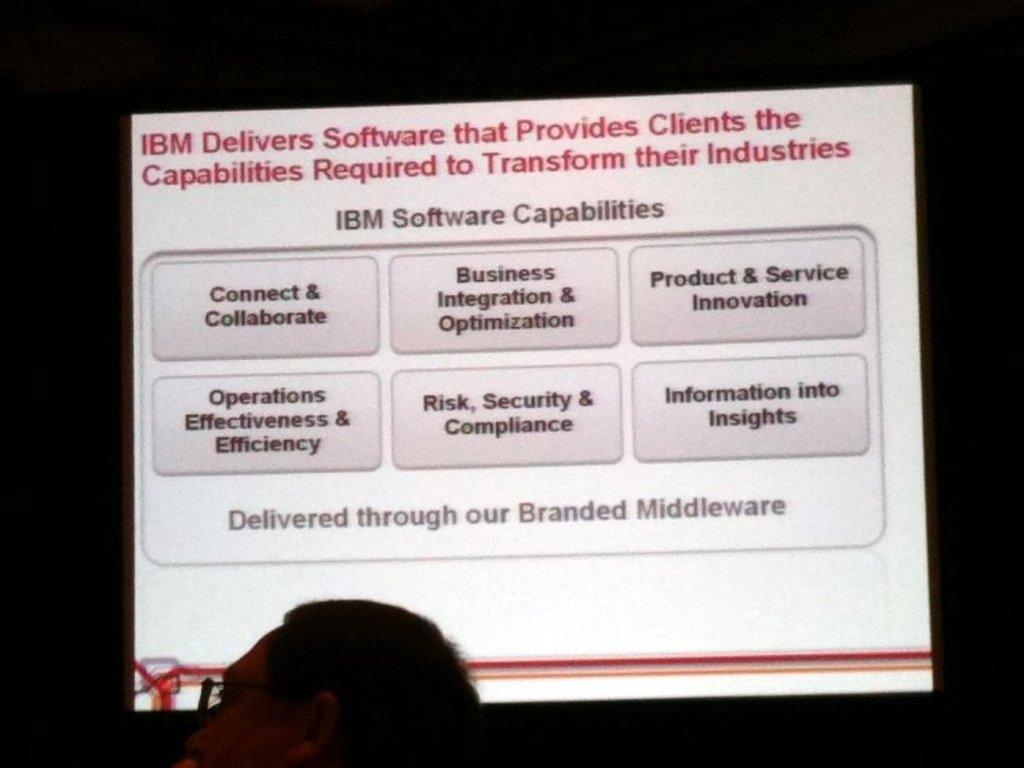In one or two sentences, can you explain what this image depicts? In this picture I can see the screen. I can see the texts. 